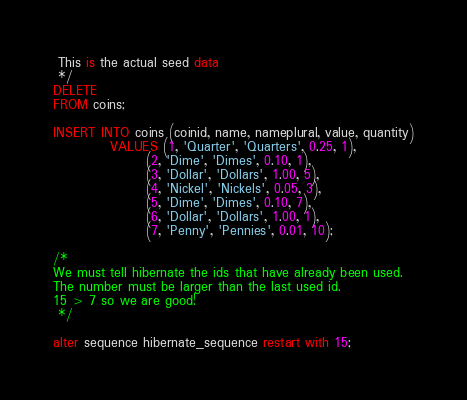<code> <loc_0><loc_0><loc_500><loc_500><_SQL_> This is the actual seed data
 */
DELETE
FROM coins;

INSERT INTO coins (coinid, name, nameplural, value, quantity)
           VALUES (1, 'Quarter', 'Quarters', 0.25, 1),
                  (2, 'Dime', 'Dimes', 0.10, 1),
                  (3, 'Dollar', 'Dollars', 1.00, 5),
                  (4, 'Nickel', 'Nickels', 0.05, 3),
                  (5, 'Dime', 'Dimes', 0.10, 7),
                  (6, 'Dollar', 'Dollars', 1.00, 1),
                  (7, 'Penny', 'Pennies', 0.01, 10);

/*
We must tell hibernate the ids that have already been used.
The number must be larger than the last used id.
15 > 7 so we are good!
 */

alter sequence hibernate_sequence restart with 15;</code> 